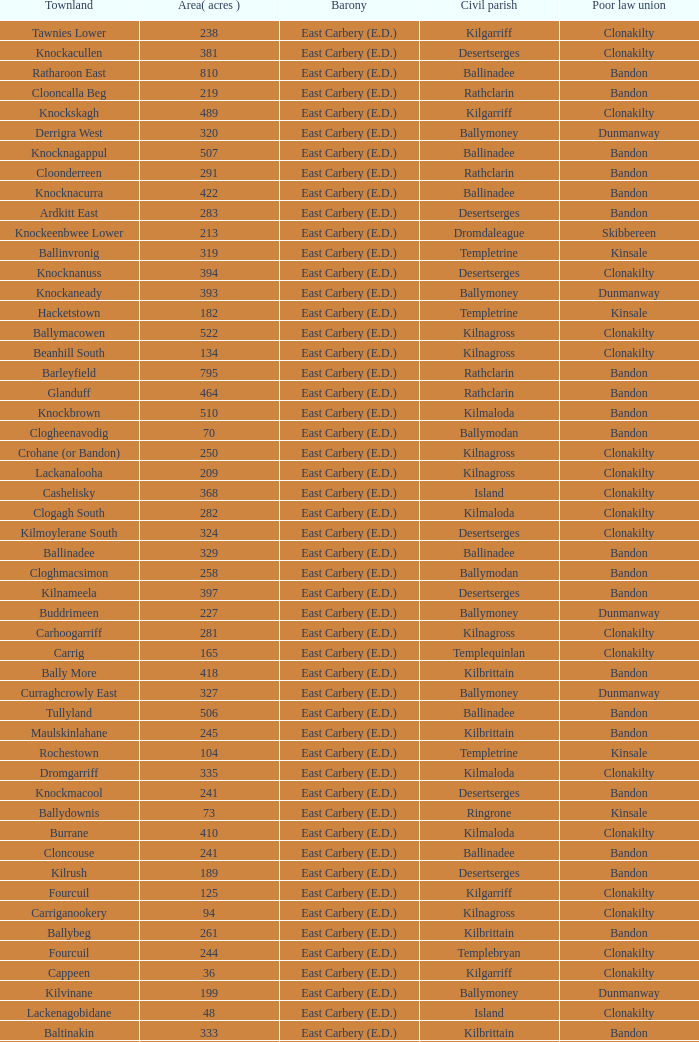What is the poor law union of the Ardacrow townland? Bandon. 